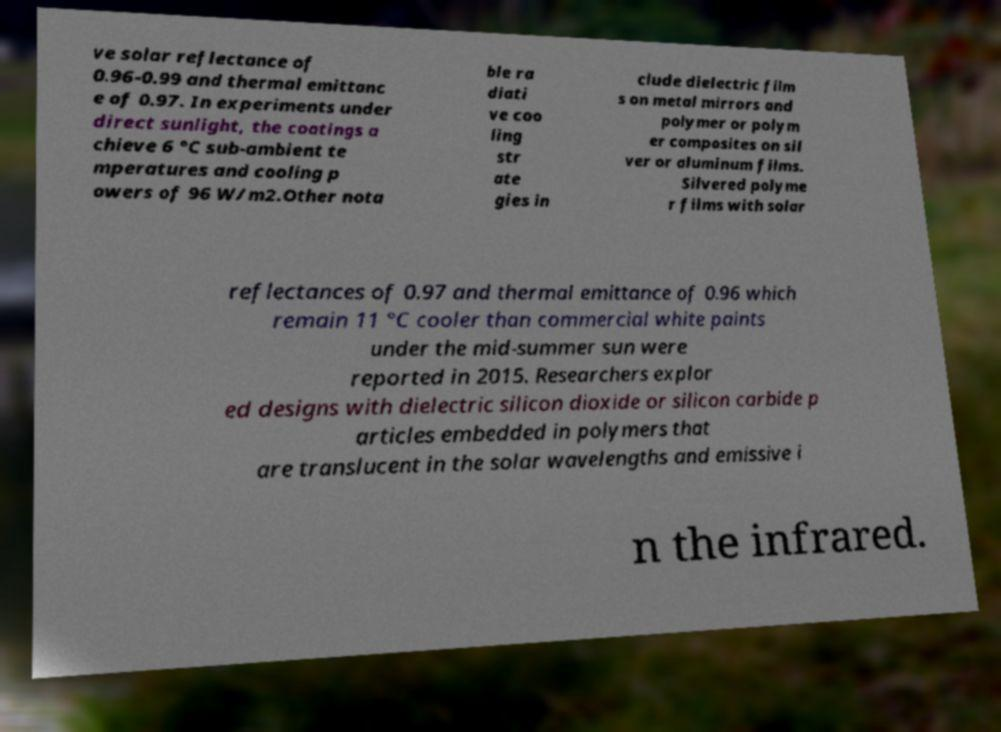I need the written content from this picture converted into text. Can you do that? ve solar reflectance of 0.96-0.99 and thermal emittanc e of 0.97. In experiments under direct sunlight, the coatings a chieve 6 °C sub-ambient te mperatures and cooling p owers of 96 W/m2.Other nota ble ra diati ve coo ling str ate gies in clude dielectric film s on metal mirrors and polymer or polym er composites on sil ver or aluminum films. Silvered polyme r films with solar reflectances of 0.97 and thermal emittance of 0.96 which remain 11 °C cooler than commercial white paints under the mid-summer sun were reported in 2015. Researchers explor ed designs with dielectric silicon dioxide or silicon carbide p articles embedded in polymers that are translucent in the solar wavelengths and emissive i n the infrared. 